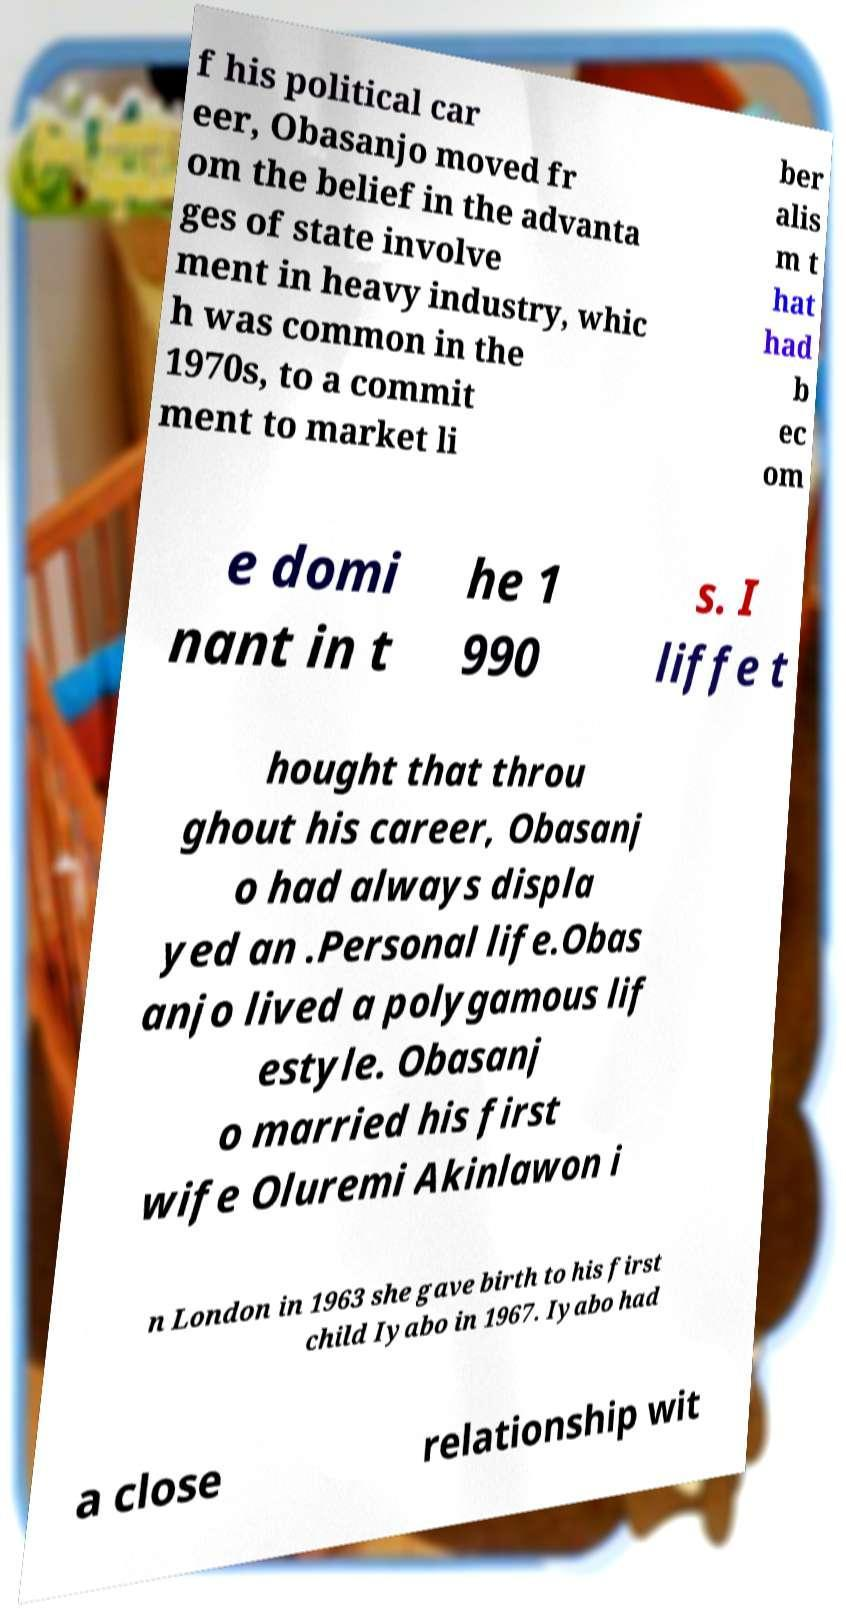Could you assist in decoding the text presented in this image and type it out clearly? f his political car eer, Obasanjo moved fr om the belief in the advanta ges of state involve ment in heavy industry, whic h was common in the 1970s, to a commit ment to market li ber alis m t hat had b ec om e domi nant in t he 1 990 s. I liffe t hought that throu ghout his career, Obasanj o had always displa yed an .Personal life.Obas anjo lived a polygamous lif estyle. Obasanj o married his first wife Oluremi Akinlawon i n London in 1963 she gave birth to his first child Iyabo in 1967. Iyabo had a close relationship wit 